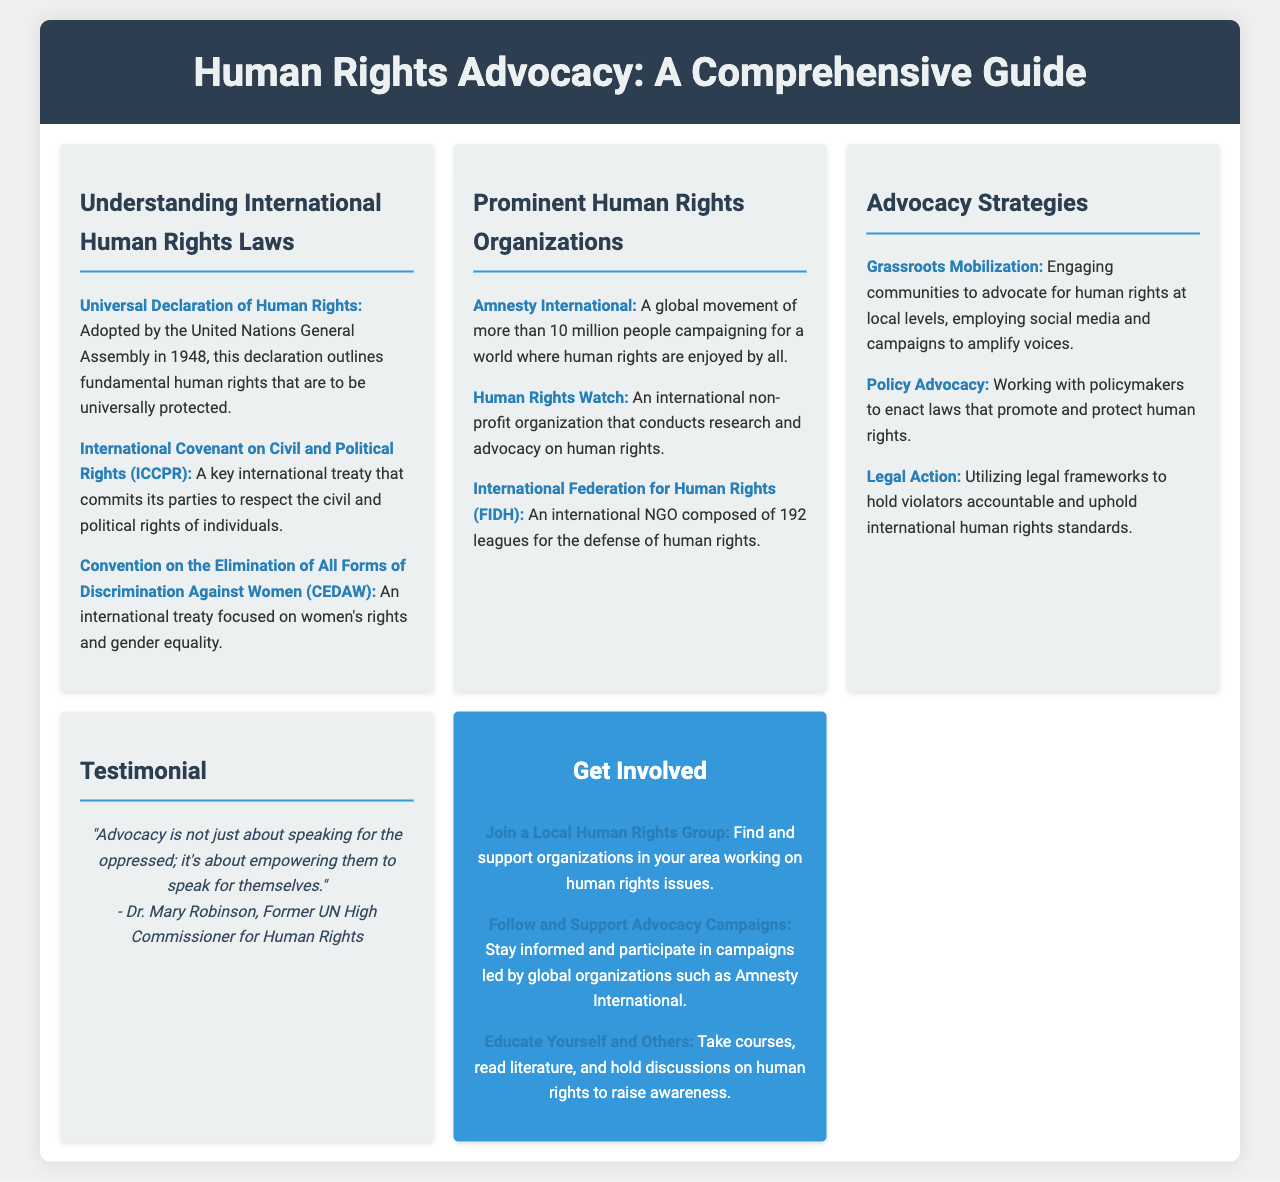What is the title of the brochure? The title is stated at the top of the document, providing a comprehensive overview of the content.
Answer: Human Rights Advocacy: A Comprehensive Guide When was the Universal Declaration of Human Rights adopted? This information is provided in the section on International Human Rights Laws, indicating its historical significance.
Answer: 1948 Which organization is described as a global movement of more than 10 million people? This refers to a specific organization mentioned in the Organizations section that campaigns for human rights globally.
Answer: Amnesty International What is one strategy for advocacy mentioned in the document? The document lists various strategies for advocacy and highlights one of them.
Answer: Grassroots Mobilization Who is the former UN High Commissioner for Human Rights quoted in the testimonial? The testimonial gives a name to a notable figure recognized for their contribution to human rights advocacy.
Answer: Dr. Mary Robinson What does the document suggest to educate oneself and others? This part of the Call-to-Action section encourages personal growth and awareness about human rights issues.
Answer: Take courses How many leagues compose the International Federation for Human Rights (FIDH)? This is stated in the prominent organizations section, giving insight into the scale of this organization.
Answer: 192 What type of advocacy involves working with policymakers? The document categorizes different types of advocacy strategies and provides the title of this specific one.
Answer: Policy Advocacy 